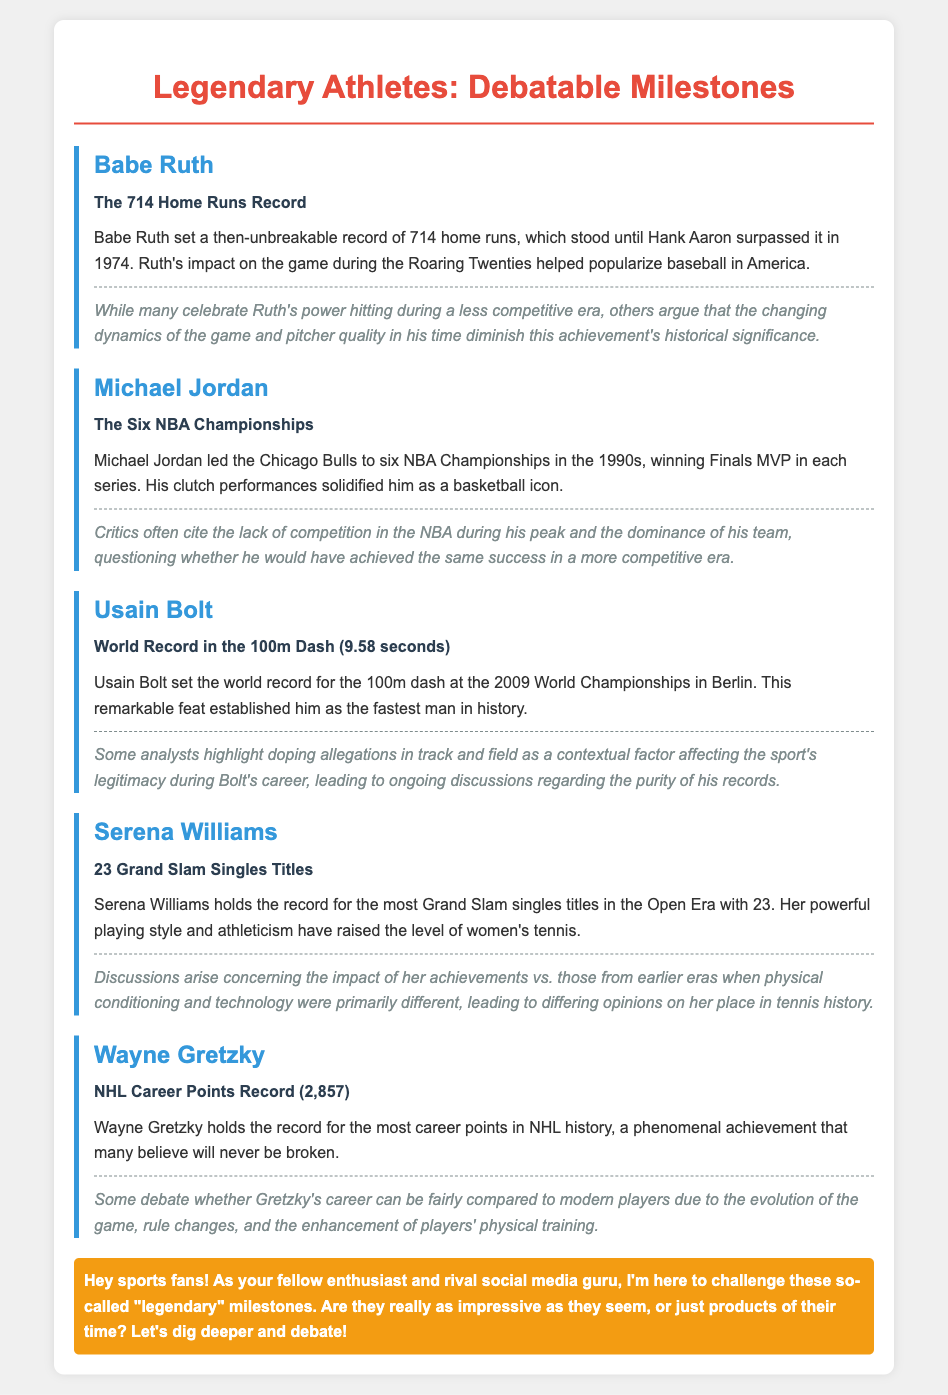What athlete set a record of 714 home runs? Babe Ruth is mentioned in the document as the athlete who set the record of 714 home runs.
Answer: Babe Ruth How many NBA Championships did Michael Jordan win? The document states that Michael Jordan led the Chicago Bulls to six NBA Championships.
Answer: Six What was Usain Bolt's world record time in the 100m dash? The document indicates that Usain Bolt set the world record for the 100m dash at 9.58 seconds.
Answer: 9.58 seconds How many Grand Slam singles titles does Serena Williams hold? The document lists that Serena Williams holds 23 Grand Slam singles titles in the Open Era.
Answer: 23 What is Wayne Gretzky's career points record? According to the document, Wayne Gretzky holds the record for the most career points in NHL history with 2,857 points.
Answer: 2,857 What era is associated with Serena Williams' achievements? The document mentions that Serena Williams' achievements are tied to the Open Era in tennis.
Answer: Open Era What is a common criticism of Michael Jordan's championships? The document highlights that critics often cite the lack of competition in the NBA during his peak as a criticism.
Answer: Lack of competition Which record held by Babe Ruth was surpassed in 1974? The document notes that Babe Ruth's 714 home runs record was surpassed by Hank Aaron in 1974.
Answer: 714 home runs What major concern surrounds Usain Bolt's records? The document brings up doping allegations in track and field as a concern surrounding Usain Bolt's records.
Answer: Doping allegations 